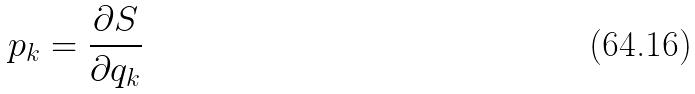Convert formula to latex. <formula><loc_0><loc_0><loc_500><loc_500>p _ { k } = \frac { \partial S } { \partial q _ { k } }</formula> 